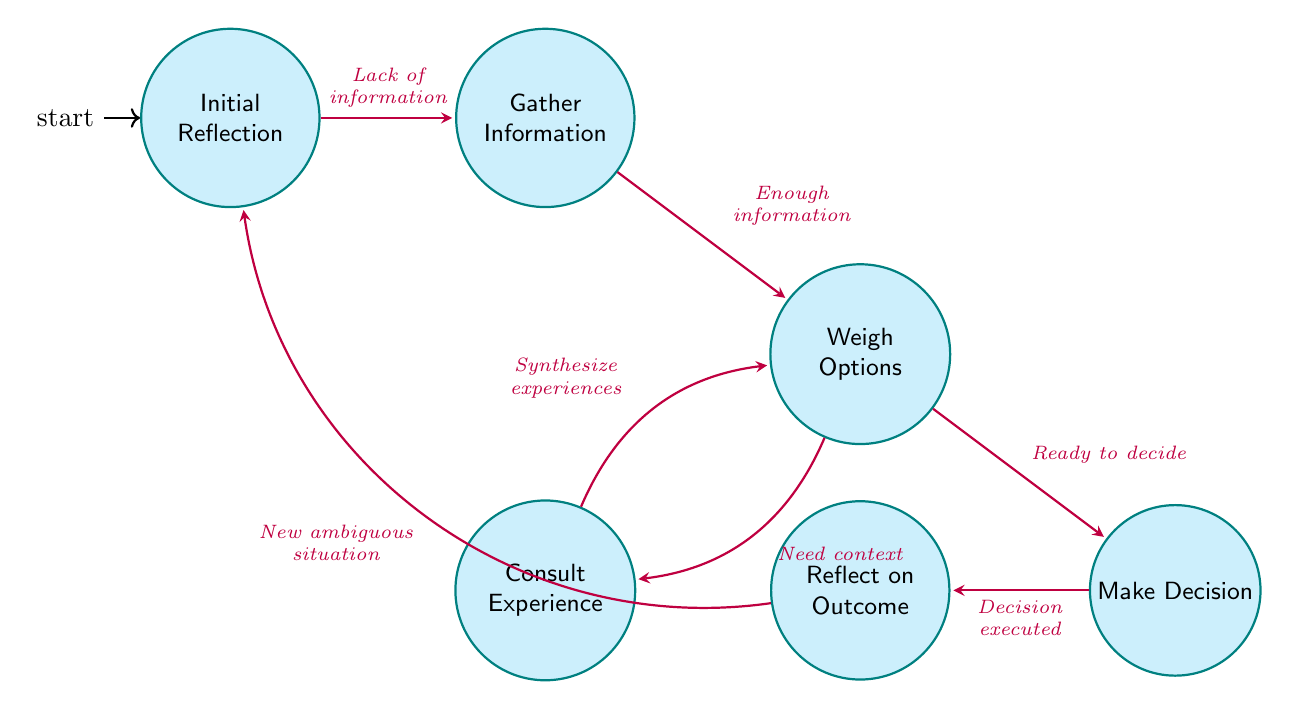What is the initial state of the FSM? The initial state of the Finite State Machine (FSM) is labeled "Initial Reflection." It is the starting point where Dave begins his decision-making process.
Answer: Initial Reflection How many states are present in the FSM? The diagram lists six distinct states: Initial Reflection, Gather Information, Weigh Options, Consult Experience, Make Decision, and Reflect on Outcome. Therefore, there are six states in total.
Answer: Six What transition occurs after "Gather Information"? After "Gather Information," the transition leads to "Weigh Options," which occurs when Dave collects enough relevant information.
Answer: Weigh Options Which state reflects on past experiences? The state that reflects on past experiences is "Consult Experience." This phase helps Dave in evaluating current options by looking back at what he has learned.
Answer: Consult Experience What is the final state in the decision-making process? The final state in the decision-making process is "Reflect on Outcome." After making a decision, Dave reviews the outcomes, thus concluding the process until a new situation arises.
Answer: Reflect on Outcome How does Dave transition from "Weigh Options" to "Make Decision"? Dave transitions from "Weigh Options" to "Make Decision" when he feels ready to decide. This indicates a point where evaluation of options has led to a conclusion.
Answer: Ready to decide What condition leads Dave back to "Initial Reflection"? The condition that leads Dave back to "Initial Reflection" is the encounter of a new ambiguous situation. This transition acknowledges that the decision-making process is cyclical and ongoing.
Answer: New ambiguous situation How many transitions are there in the FSM? There are a total of seven transitions connecting different states within the FSM, highlighting the various pathways through the decision-making process.
Answer: Seven What is the condition for transitioning from "Consult Experience" back to "Weigh Options"? The condition for transitioning from "Consult Experience" back to "Weigh Options" is when Dave synthesizes past experiences with current options, allowing him to better evaluate his choices.
Answer: Synthesize experiences 